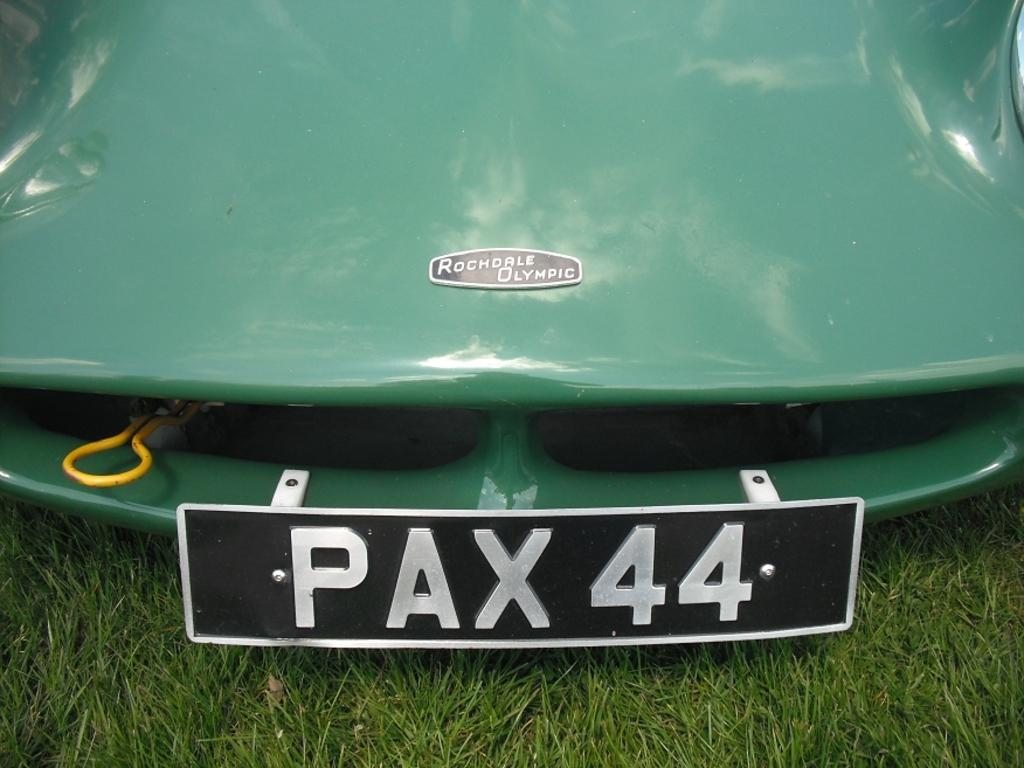<image>
Render a clear and concise summary of the photo. A license plate PAX 44 on the front of a green Rochdale Olympic. 